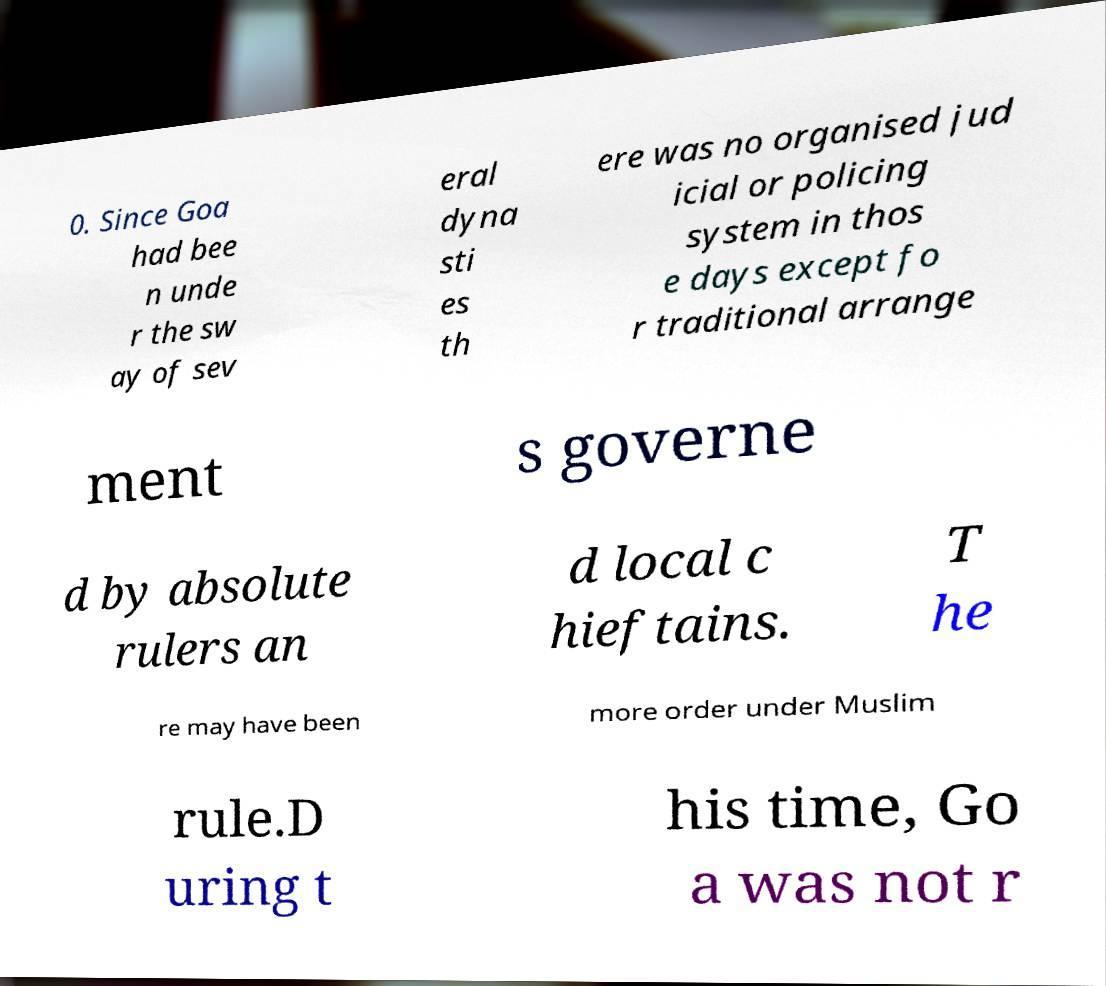For documentation purposes, I need the text within this image transcribed. Could you provide that? 0. Since Goa had bee n unde r the sw ay of sev eral dyna sti es th ere was no organised jud icial or policing system in thos e days except fo r traditional arrange ment s governe d by absolute rulers an d local c hieftains. T he re may have been more order under Muslim rule.D uring t his time, Go a was not r 